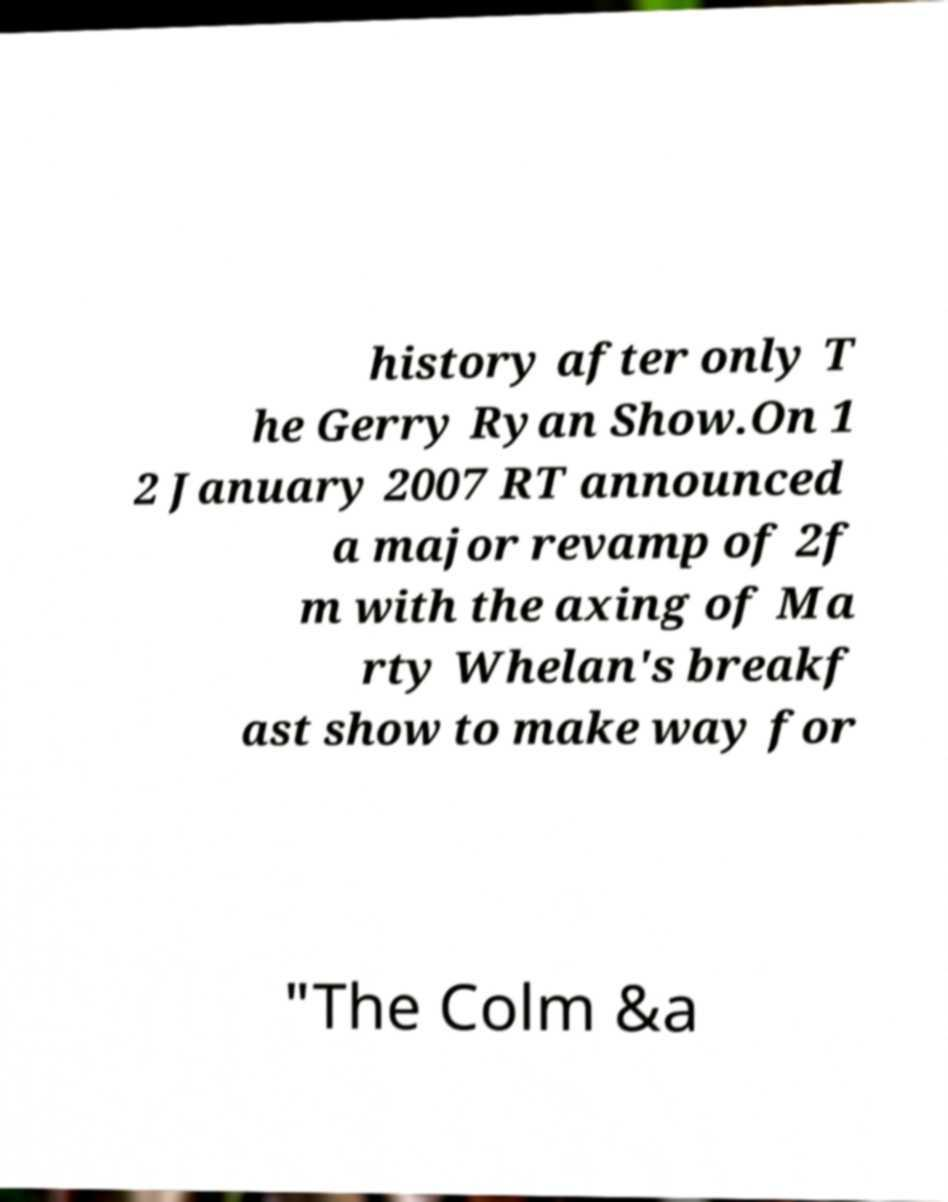Could you extract and type out the text from this image? history after only T he Gerry Ryan Show.On 1 2 January 2007 RT announced a major revamp of 2f m with the axing of Ma rty Whelan's breakf ast show to make way for "The Colm &a 